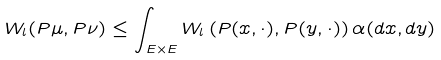Convert formula to latex. <formula><loc_0><loc_0><loc_500><loc_500>W _ { l } ( P \mu , P \nu ) \leq \int _ { E \times E } W _ { l } \left ( P ( x , \cdot ) , P ( y , \cdot ) \right ) \alpha ( d x , d y )</formula> 